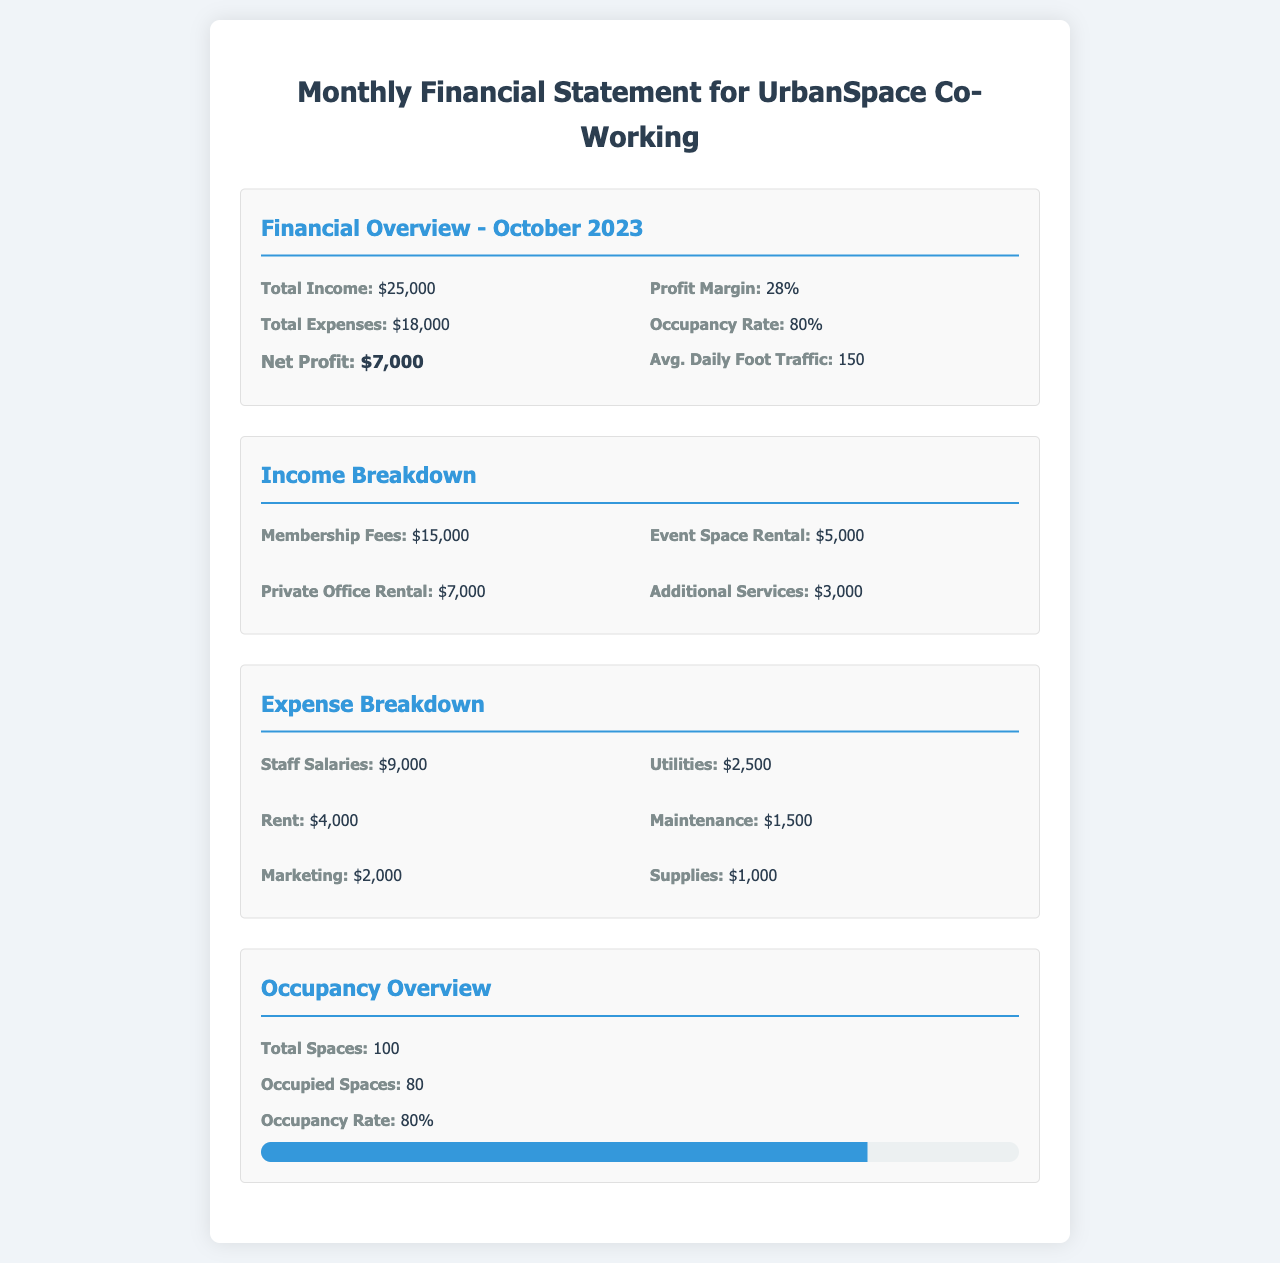What is the total income? The total income is stated in the financial overview section of the document, which is $25,000.
Answer: $25,000 What are the total expenses? The total expenses can be found in the same section, which is $18,000.
Answer: $18,000 What is the net profit? The net profit is calculated as total income minus total expenses, which is $7,000.
Answer: $7,000 What is the occupancy rate? The occupancy rate is mentioned in the financial overview section, which is 80%.
Answer: 80% What is the revenue from membership fees? The revenue from membership fees is provided in the income breakdown section, which is $15,000.
Answer: $15,000 What amount was spent on staff salaries? The amount spent on staff salaries can be found in the expense breakdown section, which is $9,000.
Answer: $9,000 What is the average daily foot traffic? The average daily foot traffic is mentioned in the financial overview, which is 150.
Answer: 150 How many total spaces are available? The total spaces are listed in the occupancy overview section, which is 100.
Answer: 100 How many spaces are occupied? The occupied spaces can be found in the occupancy overview section, which is 80.
Answer: 80 